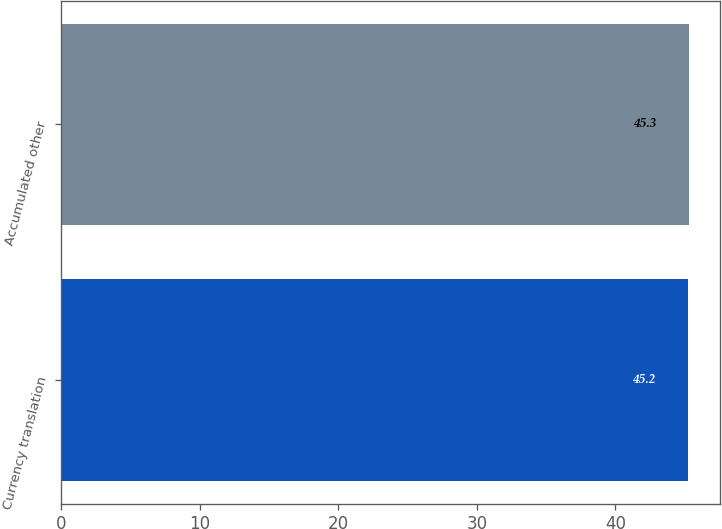Convert chart to OTSL. <chart><loc_0><loc_0><loc_500><loc_500><bar_chart><fcel>Currency translation<fcel>Accumulated other<nl><fcel>45.2<fcel>45.3<nl></chart> 